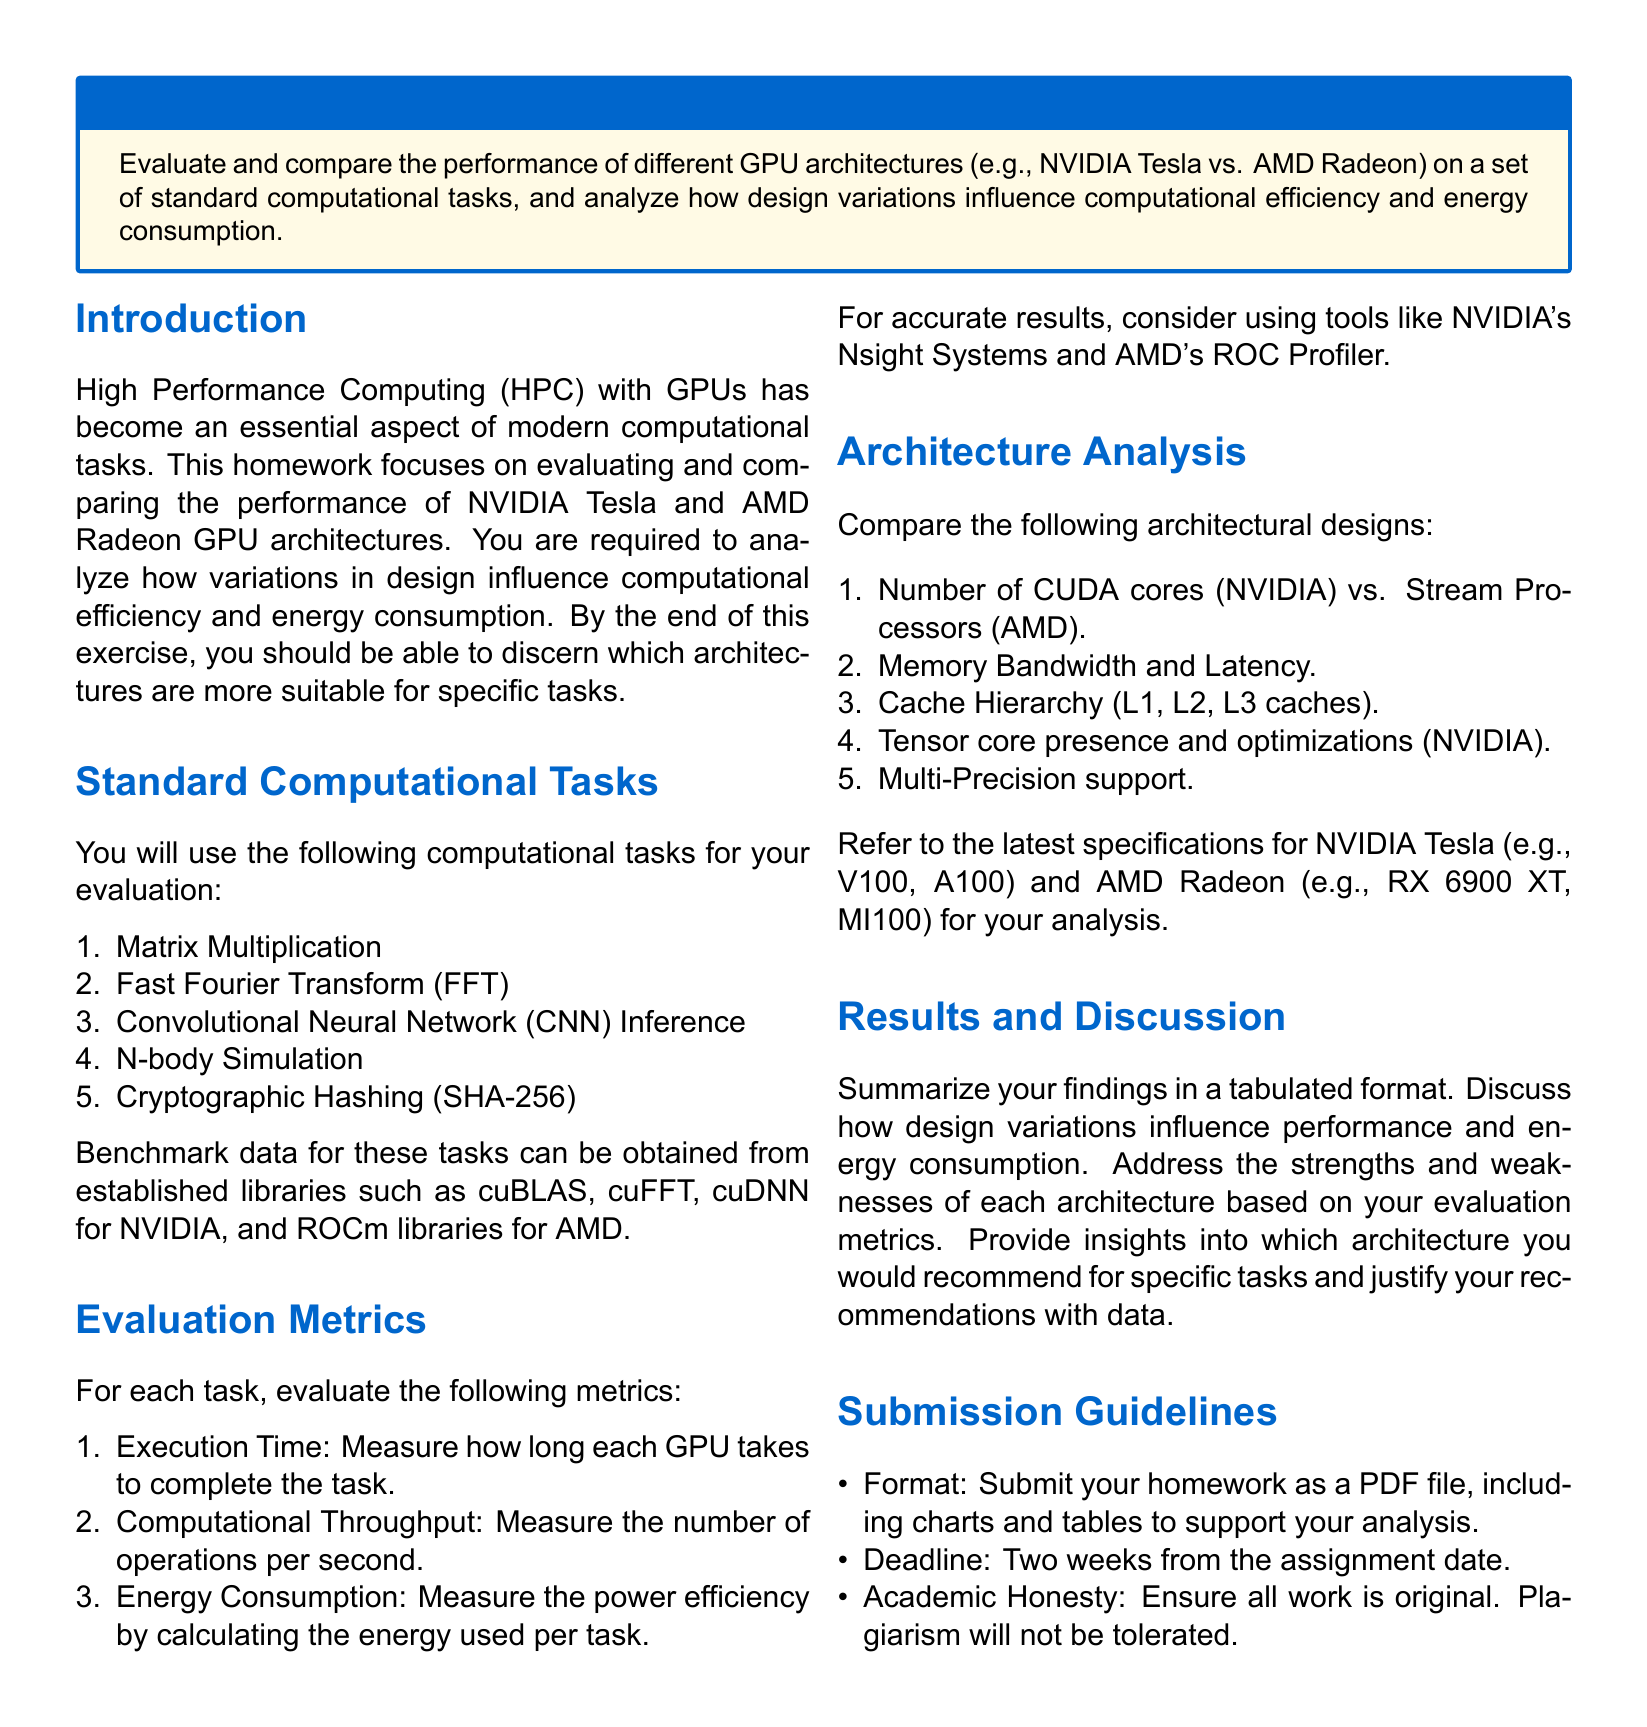What are the two GPU architectures being compared? The document explicitly mentions the two GPU architectures for comparison, which are NVIDIA Tesla and AMD Radeon.
Answer: NVIDIA Tesla and AMD Radeon How many standard computational tasks are listed for evaluation? The document states a total of five standard computational tasks to evaluate the GPU architectures.
Answer: Five What is one of the evaluation metrics for each task? The document lists specific evaluation metrics, one of which is Execution Time.
Answer: Execution Time What type of academic honesty policy is mentioned in the document? The document emphasizes that all work must be original and that plagiarism will not be tolerated.
Answer: Plagiarism will not be tolerated Which library is recommended for NVIDIA GPU benchmarking? The document suggests using cuBLAS, cuFFT, and cuDNN libraries for benchmarking on NVIDIA GPUs.
Answer: cuBLAS What is the deadline for homework submission? The document specifies that the homework must be submitted two weeks from the assignment date.
Answer: Two weeks What should the format of the homework submission be? The document outlines that the homework must be submitted as a PDF file.
Answer: PDF file Which architectural feature is present in NVIDIA GPUs? The document mentions that Tensor core presence and optimizations are a design consideration specific to NVIDIA GPUs.
Answer: Tensor core presence What kind of tasks is this homework focusing on? The document clearly states that the focus of the homework is on evaluating GPU performance for high performance computing.
Answer: Evaluating GPU performance 